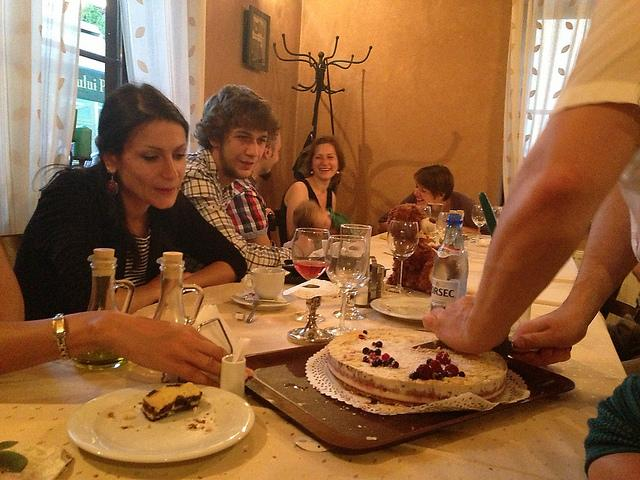What will the people shown here have for dessert? Please explain your reasoning. cheesecake. A person is cutting a cake that is cheese colored. 